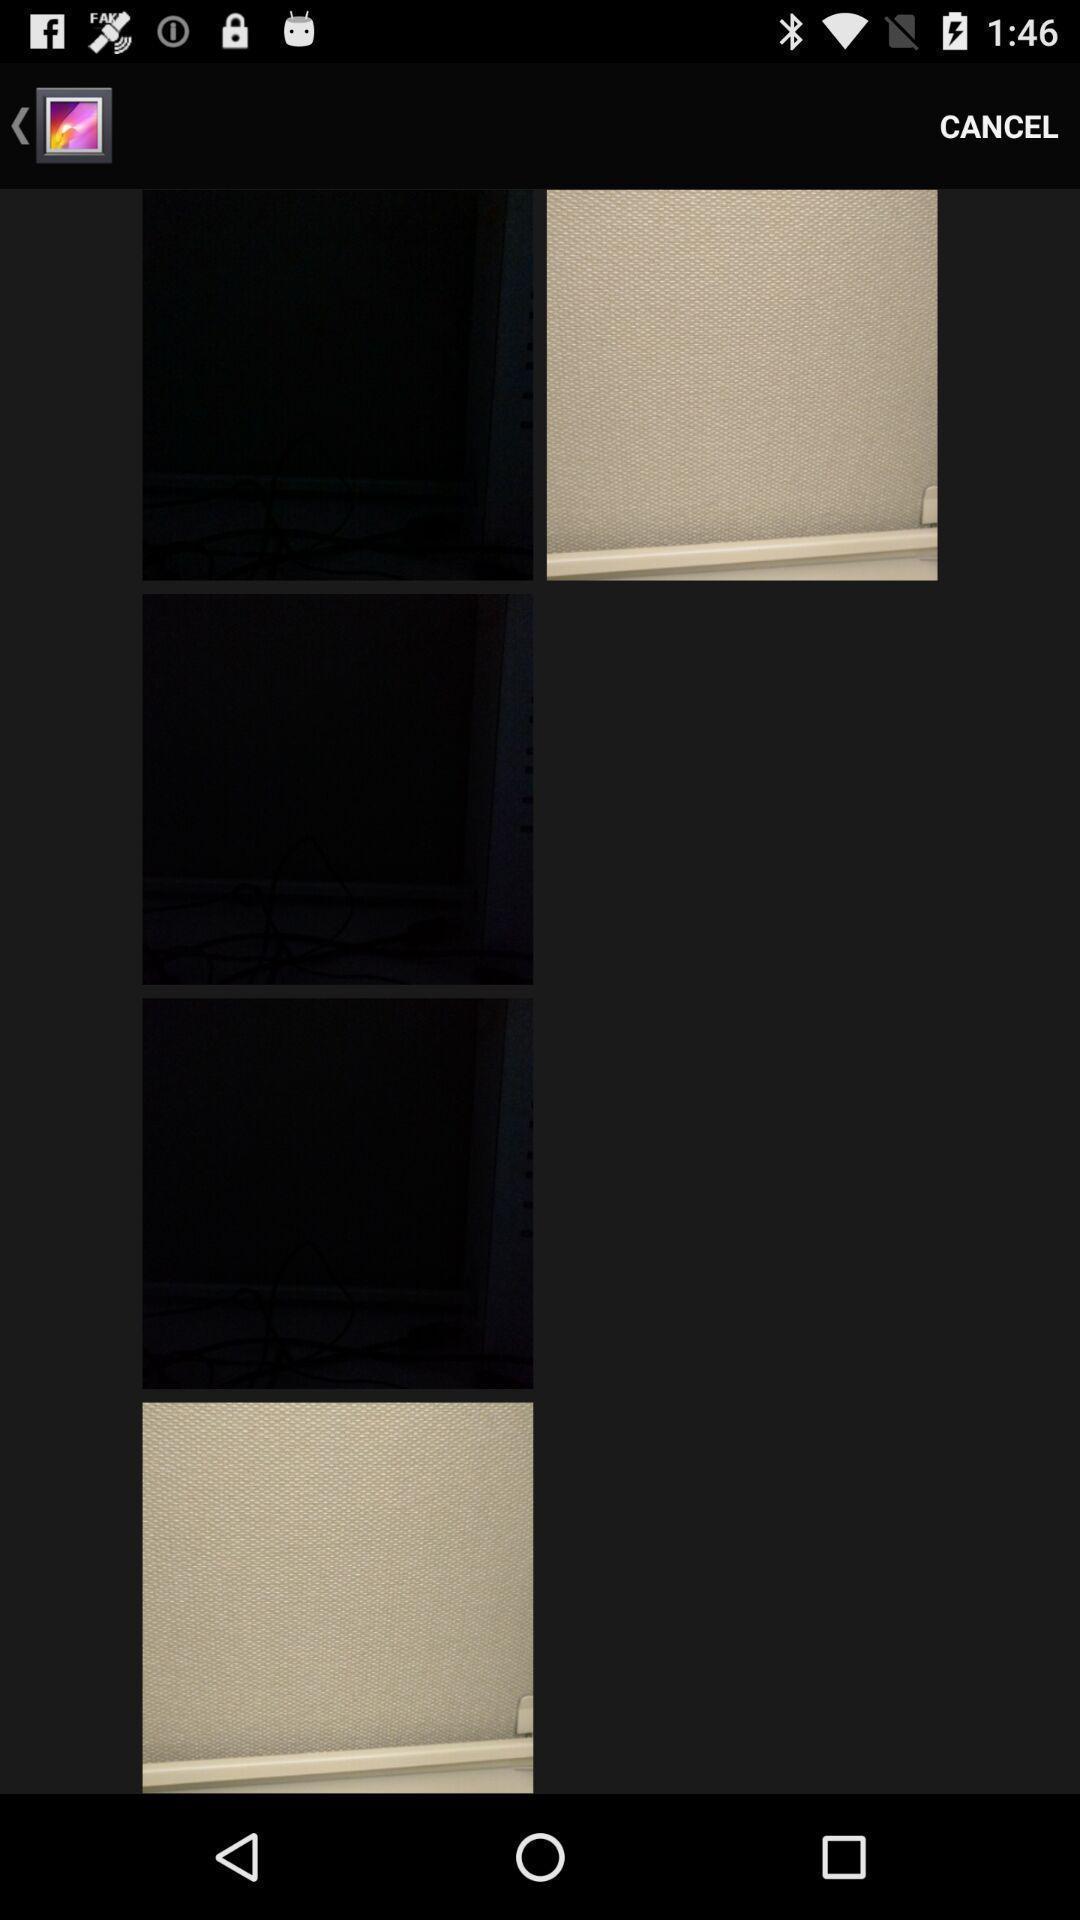Explain what's happening in this screen capture. Page showing image in gallery. 